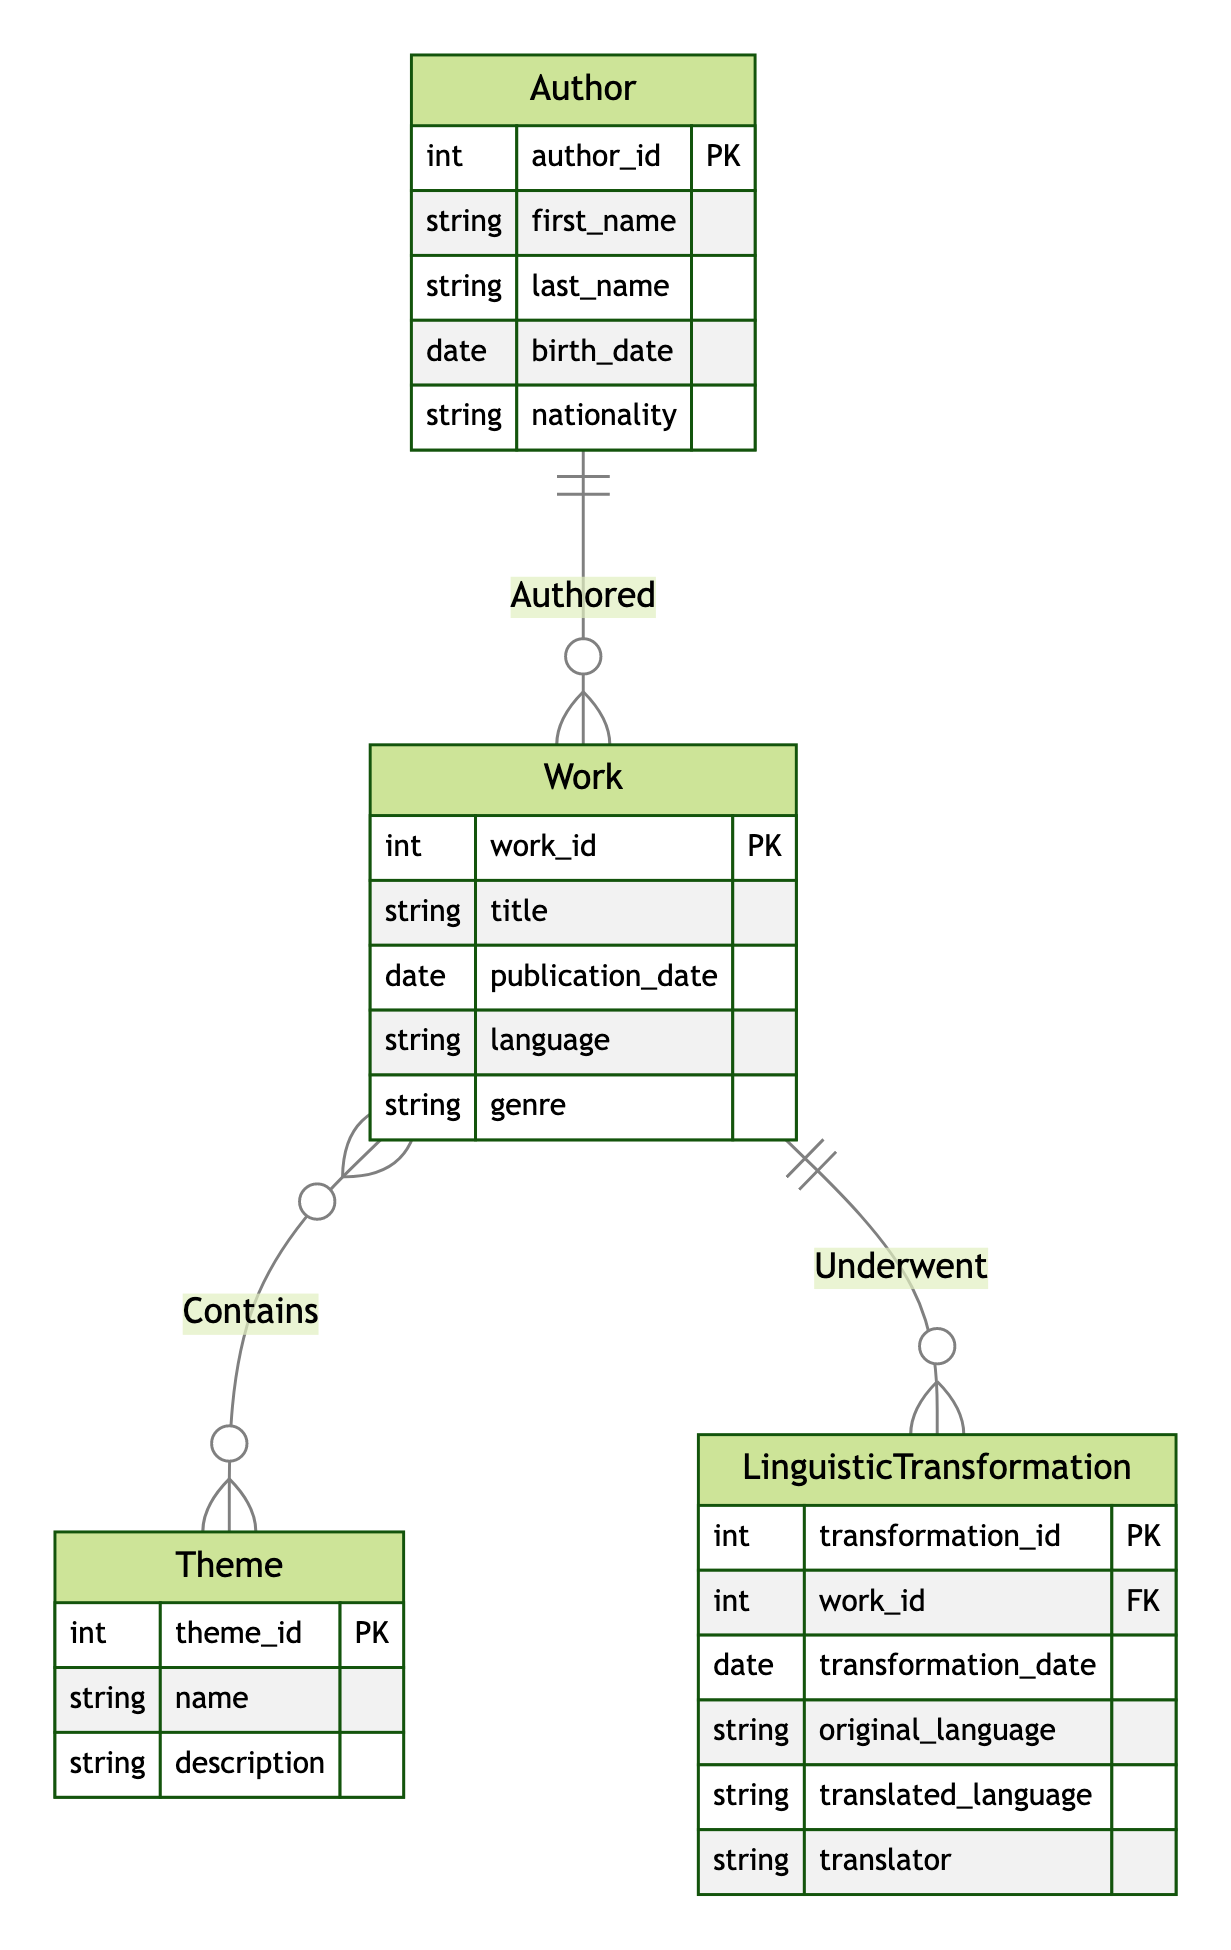What is the primary relationship between Author and Work? The diagram shows a one-to-many relationship indicated by "Authored," meaning that one Author can write multiple Works.
Answer: one-to-many How many attributes are there in the Theme entity? The Theme entity has three attributes: theme_id, name, and description. This is directly inferred from the attributes listed for the Theme entity in the diagram.
Answer: three Which entity can have multiple Themes? The relationship "Contains" indicates that a Work can include multiple Themes, as it is a many-to-many relationship between the two entities.
Answer: Work What is the role of the LinguisticTransformation entity? The LinguisticTransformation entity describes a transformation process that a Work undergoes, as indicated by the one-to-many relationship "Underwent" with the Work entity.
Answer: transformation process What do the arrows between entities represent? The arrows indicate relationships between the entities: "Authored" shows the relationship between Author and Work, "Contains" shows the relationship between Work and Theme, and "Underwent" shows the relationship between Work and LinguisticTransformation.
Answer: relationships How many total entities are depicted in this diagram? There are four entities illustrated in the diagram: Author, Work, Theme, and LinguisticTransformation, directly counted from the provided entity list.
Answer: four What is the nature of the relationship between Work and Theme? The diagram illustrates a many-to-many relationship between Work and Theme, indicating that each Work can embody multiple Themes and vice versa.
Answer: many-to-many Which entity has a foreign key reference to Work? The LinguisticTransformation entity has a foreign key reference to Work, as indicated by the work_id attribute in the LinguisticTransformation entity.
Answer: LinguisticTransformation 